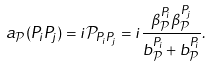<formula> <loc_0><loc_0><loc_500><loc_500>a _ { \mathcal { P } } ( P _ { i } P _ { j } ) = i \mathcal { P } _ { P _ { i } P _ { j } } = i \frac { \beta _ { \mathcal { P } } ^ { P _ { i } } \beta _ { \mathcal { P } } ^ { P _ { j } } } { b _ { \mathcal { P } } ^ { P _ { i } } + b _ { \mathcal { P } } ^ { P _ { i } } } .</formula> 